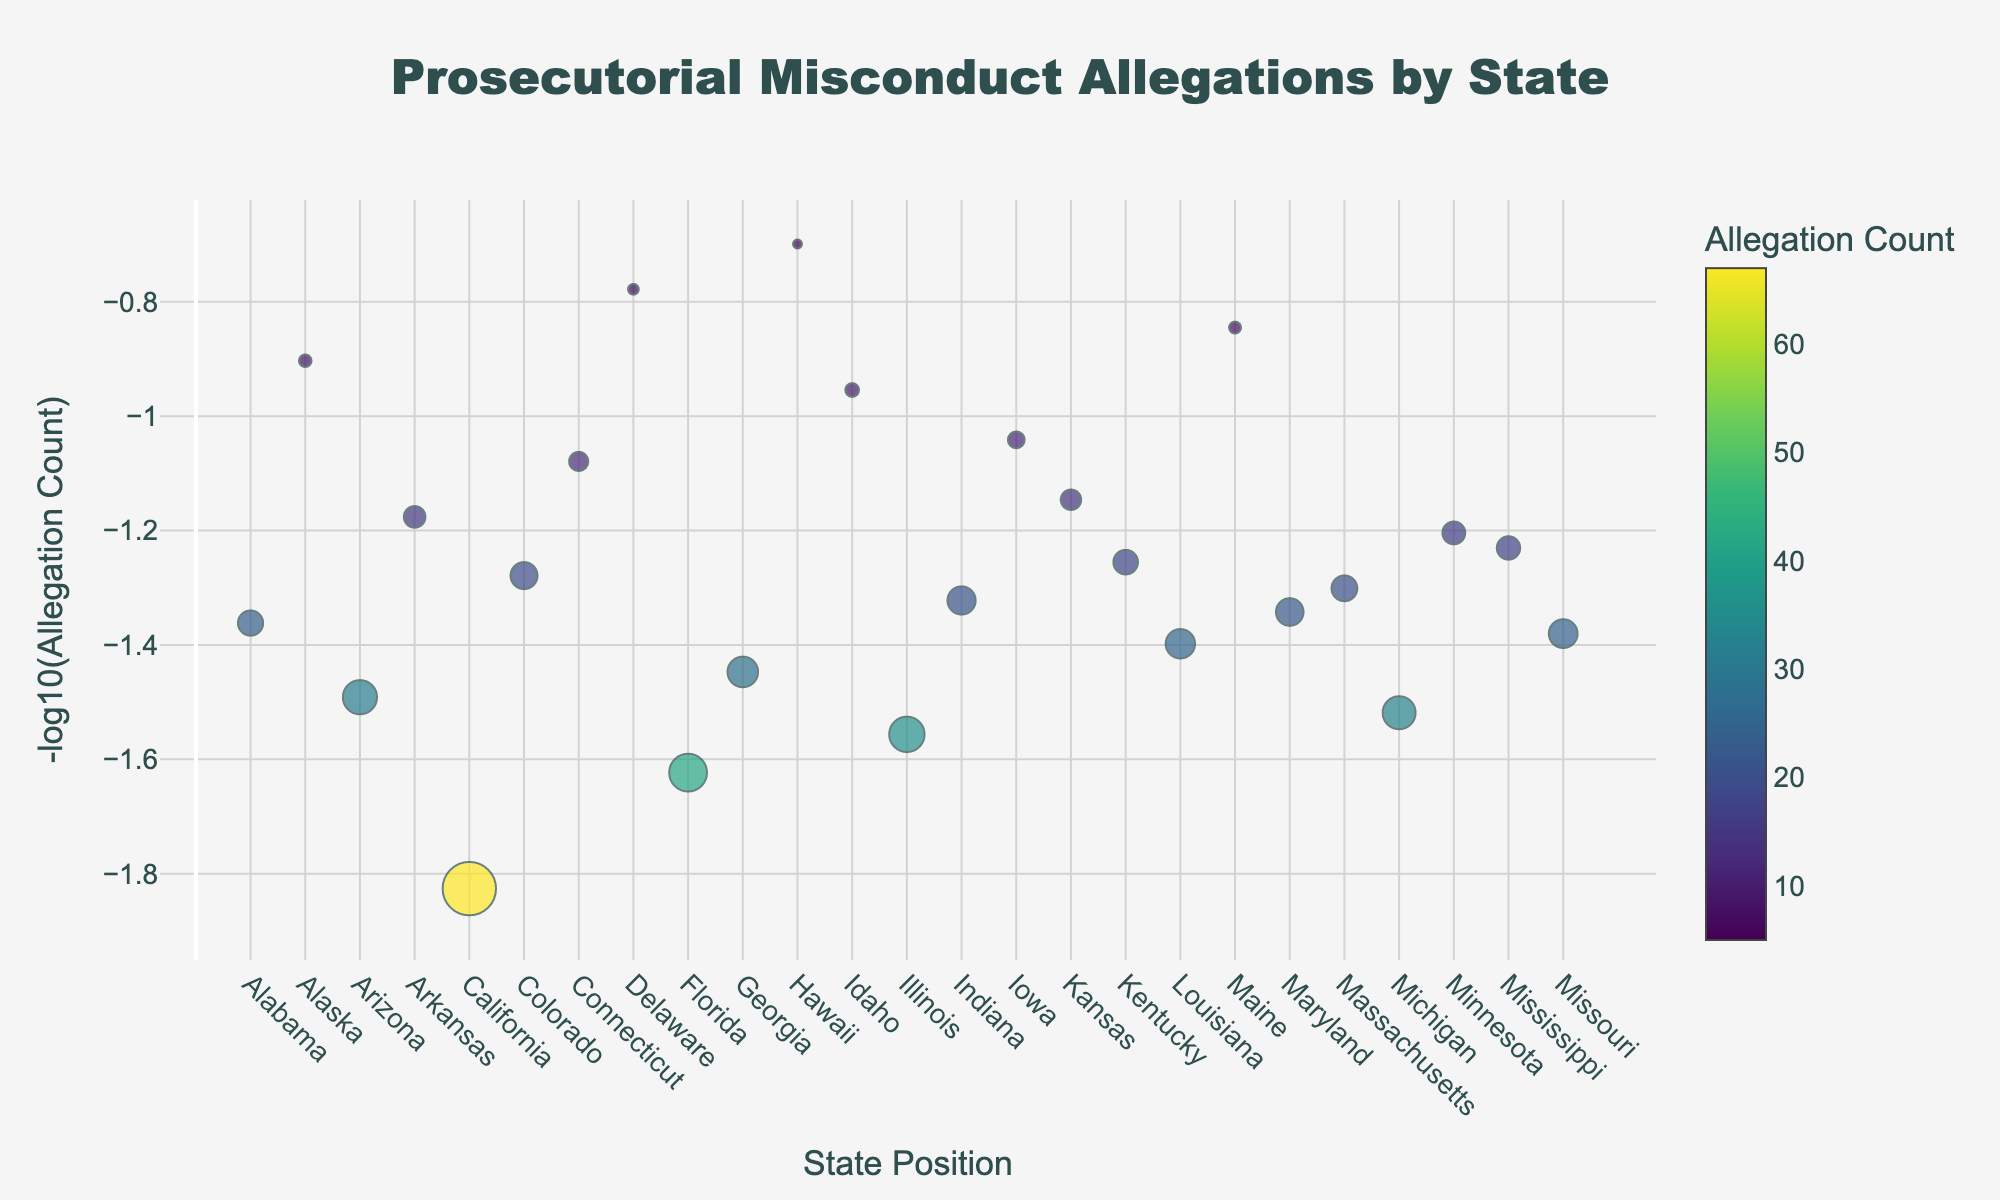What is the title of the figure? The title is usually located at the top of the figure. In this case, the title is "Prosecutorial Misconduct Allegations by State."
Answer: Prosecutorial Misconduct Allegations by State How many states have an allegation count greater than 40? To answer this question, look at the colors of the markers, as they represent the allegation count. Notice the color bar to help identify counts greater than 40. In the figure, California and Florida have allegation counts greater than 40.
Answer: 2 Which state has the highest Impact Score and what is it? The Impact Score is represented by the size of the markers. The largest marker corresponds to California, and based on the text provided, California has an Impact Score of 8.9.
Answer: California, 8.9 What is the range of the -log10(Allegation Count) values displayed on the y-axis? The y-axis title is "-log10(Allegation Count)." To find the range, observe the lowest and highest positions of markers on the y-axis. The lowest is for states with the highest allegation count, and the highest is for states with the lowest counts. Based on the values in AllegationCount, the range is approximately 0 to just above 1. One of the lowest values is for California, and one of the highest values is for Delaware.
Answer: Approximately 0 to 1.5 Which state has the lowest allegation count and what is its Impact Score? The lowest allegation count corresponds to the lightest color on the color scale. In the figure, the lightest marker corresponds to Hawaii with an Impact Score of 1.5.
Answer: Hawaii, 1.5 Compare the Allegation Count and Impact Score of Michigan and Missouri. At the positions indicated in the data (Michigan at 22 and Missouri at 25), the markers show varying sizes and colors. Michigan has an Allegation Count of 33 and an Impact Score of 5.5, while Missouri has an Allegation Count of 24 and an Impact Score of 4.8.
Answer: Michigan: 33, 5.5; Missouri: 24, 4.8 How does the number of allegations in Alabama compare to Arizona? Referring to the colors and positions of the markers, Alabama is at position 1 and Arizona is at position 3. Alabama has an Allegation Count of 23, while Arizona has an Allegation Count of 31. Arizona has more allegations than Alabama.
Answer: Arizona has more allegations than Alabama What is the average Impact Score of states with an Allegation Count greater than 30? The states with Allegation Counts greater than 30 are Arizona, California, Florida, and Illinois. Their Impact Scores are 5.7, 8.9, 6.3, and 5.9 respectively. The average is calculated as (5.7 + 8.9 + 6.3 + 5.9) / 4 = 6.7.
Answer: 6.7 Which state has the highest Position value and what is its Allegation Count? The Position values indicate the order of the states. The highest Position value is for Missouri at position 25. Missouri has an Allegation Count of 24.
Answer: Missouri, 24 